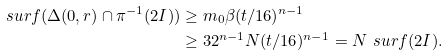Convert formula to latex. <formula><loc_0><loc_0><loc_500><loc_500>\ s u r f ( \Delta ( 0 , r ) \cap \pi ^ { - 1 } ( 2 I ) ) & \geq m _ { 0 } \beta ( t / 1 6 ) ^ { n - 1 } \\ & \geq 3 2 ^ { n - 1 } N ( t / 1 6 ) ^ { n - 1 } = N \ s u r f ( 2 I ) .</formula> 